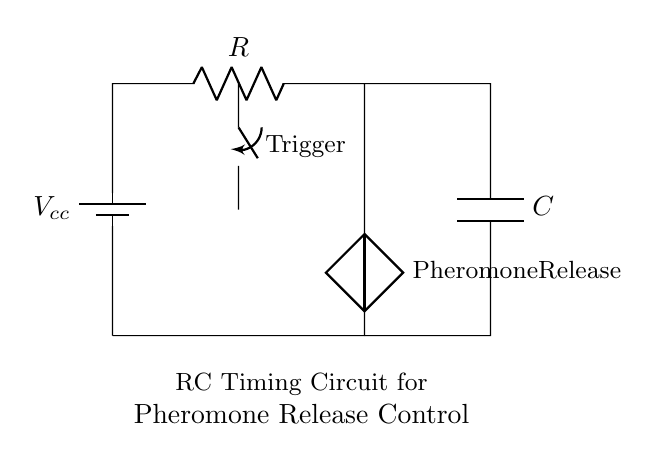What type of circuit is shown? This is an RC timing circuit, indicated by the presence of a resistor and a capacitor. It is specifically designed for timing applications, likely to control the release of pheromones in insect behavior experiments.
Answer: RC timing circuit What is the role of the switch in this circuit? The switch is labeled as "Trigger" and serves to initiate the timing process of the circuit. When closed, it allows current to flow, charging the capacitor and starting the timing interval.
Answer: Trigger What is the function of the capacitor in this circuit? The capacitor stores electrical energy when charged and releases it over time, controlling the timing for the release of pheromones based on its discharge rate.
Answer: Timing control What is the voltage supply in this circuit? The voltage supply is indicated by the symbol representing the battery, labeled as Vcc. This is the source voltage that powers the circuit.
Answer: Vcc How do the resistor and capacitor determine the timing? The timing is determined by the RC time constant, which is the product of the resistance (R) and capacitance (C). This time constant dictates how quickly the capacitor charges and discharges.
Answer: RC time constant What happens when the switch is turned on? When the switch is closed, it creates a complete circuit, allowing current to flow. This current charges the capacitor until it reaches a certain voltage, which can then activate the pheromone release.
Answer: Charging the capacitor What is the significance of the pheromone release component? The pheromone release component symbolizes an output of the circuit influenced by the capacitor’s discharge, important for controlling insect behavior during experiments.
Answer: Output control 